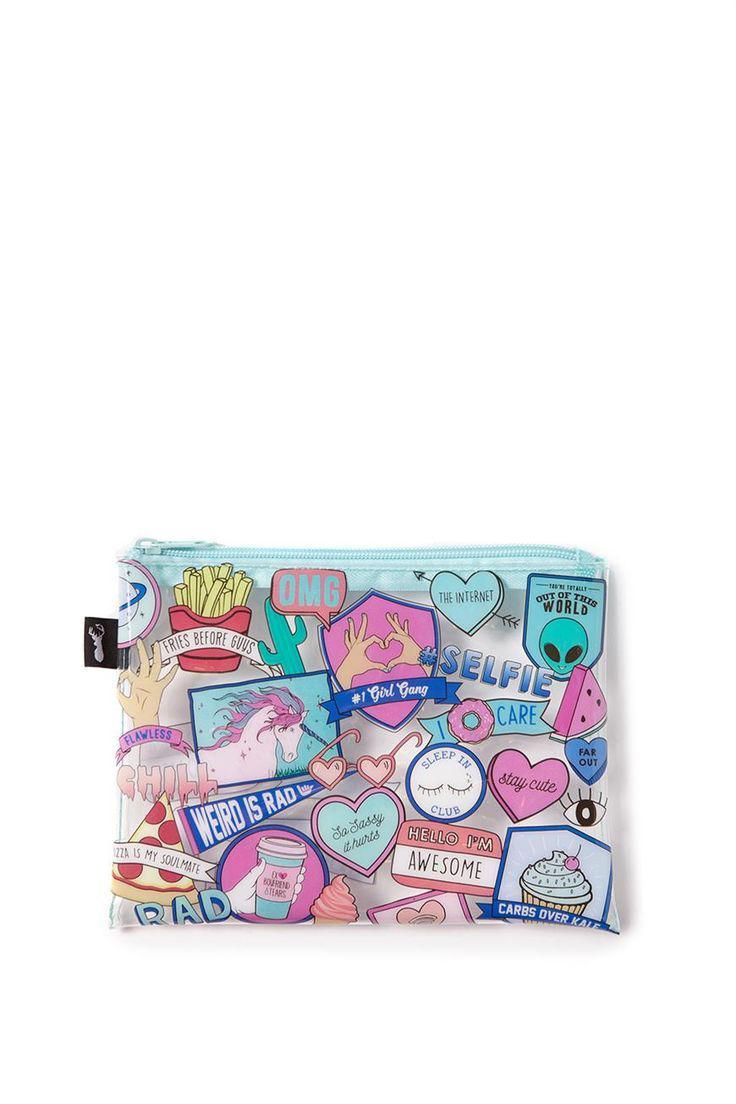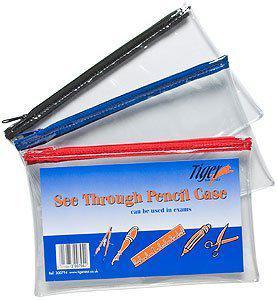The first image is the image on the left, the second image is the image on the right. For the images shown, is this caption "One pencil bag has a design." true? Answer yes or no. Yes. The first image is the image on the left, the second image is the image on the right. Given the left and right images, does the statement "There are three pencil cases in at least one of the images." hold true? Answer yes or no. Yes. 